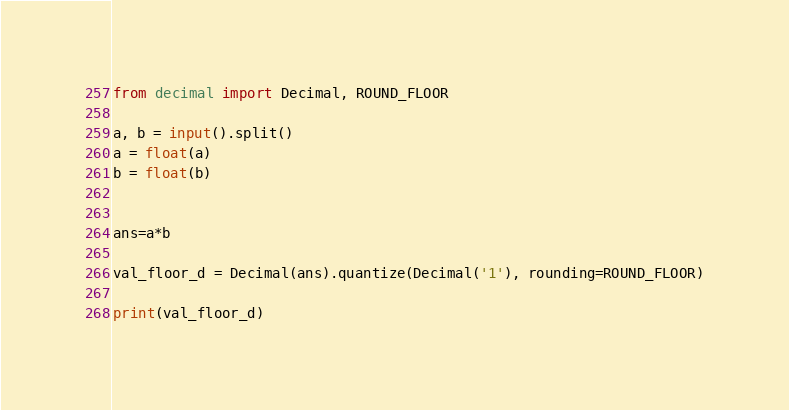Convert code to text. <code><loc_0><loc_0><loc_500><loc_500><_Python_>from decimal import Decimal, ROUND_FLOOR

a, b = input().split()
a = float(a)
b = float(b)


ans=a*b

val_floor_d = Decimal(ans).quantize(Decimal('1'), rounding=ROUND_FLOOR)

print(val_floor_d)</code> 